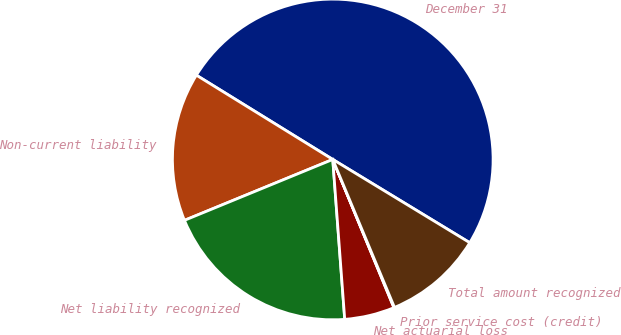<chart> <loc_0><loc_0><loc_500><loc_500><pie_chart><fcel>December 31<fcel>Non-current liability<fcel>Net liability recognized<fcel>Net actuarial loss<fcel>Prior service cost (credit)<fcel>Total amount recognized<nl><fcel>49.89%<fcel>15.01%<fcel>19.99%<fcel>5.04%<fcel>0.06%<fcel>10.02%<nl></chart> 